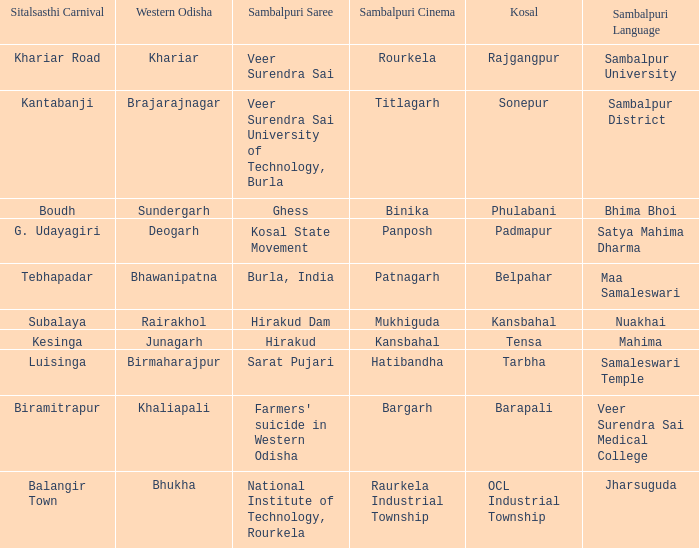What is the sambalpuri saree with a samaleswari temple as sambalpuri language? Sarat Pujari. 